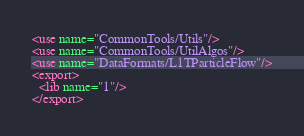<code> <loc_0><loc_0><loc_500><loc_500><_XML_><use name="CommonTools/Utils"/>
<use name="CommonTools/UtilAlgos"/>
<use name="DataFormats/L1TParticleFlow"/>
<export>
  <lib name="1"/>
</export>
</code> 